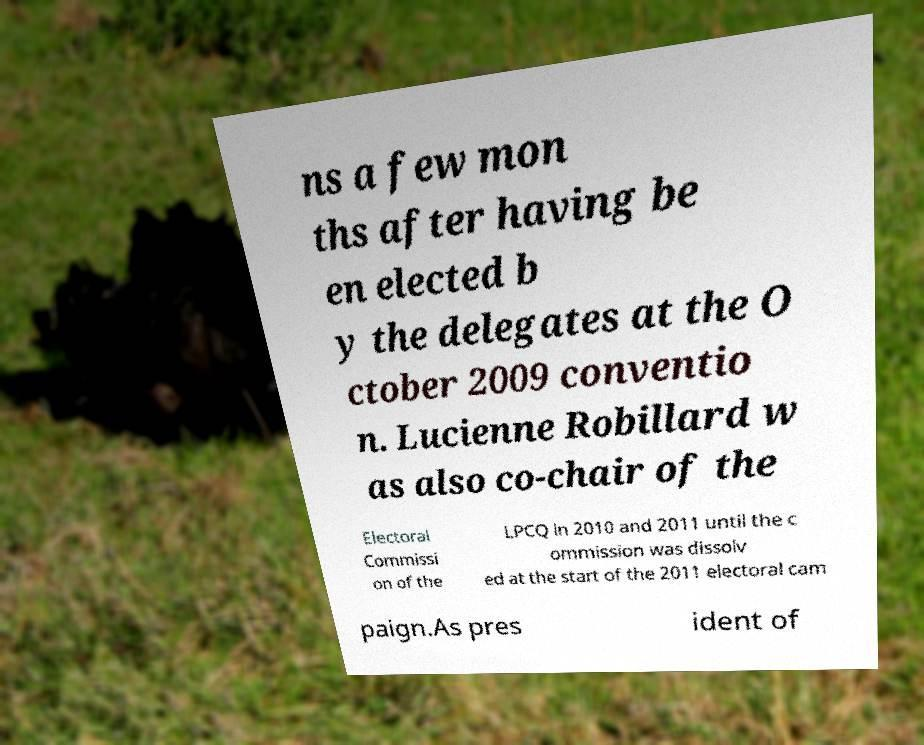Could you extract and type out the text from this image? ns a few mon ths after having be en elected b y the delegates at the O ctober 2009 conventio n. Lucienne Robillard w as also co-chair of the Electoral Commissi on of the LPCQ in 2010 and 2011 until the c ommission was dissolv ed at the start of the 2011 electoral cam paign.As pres ident of 